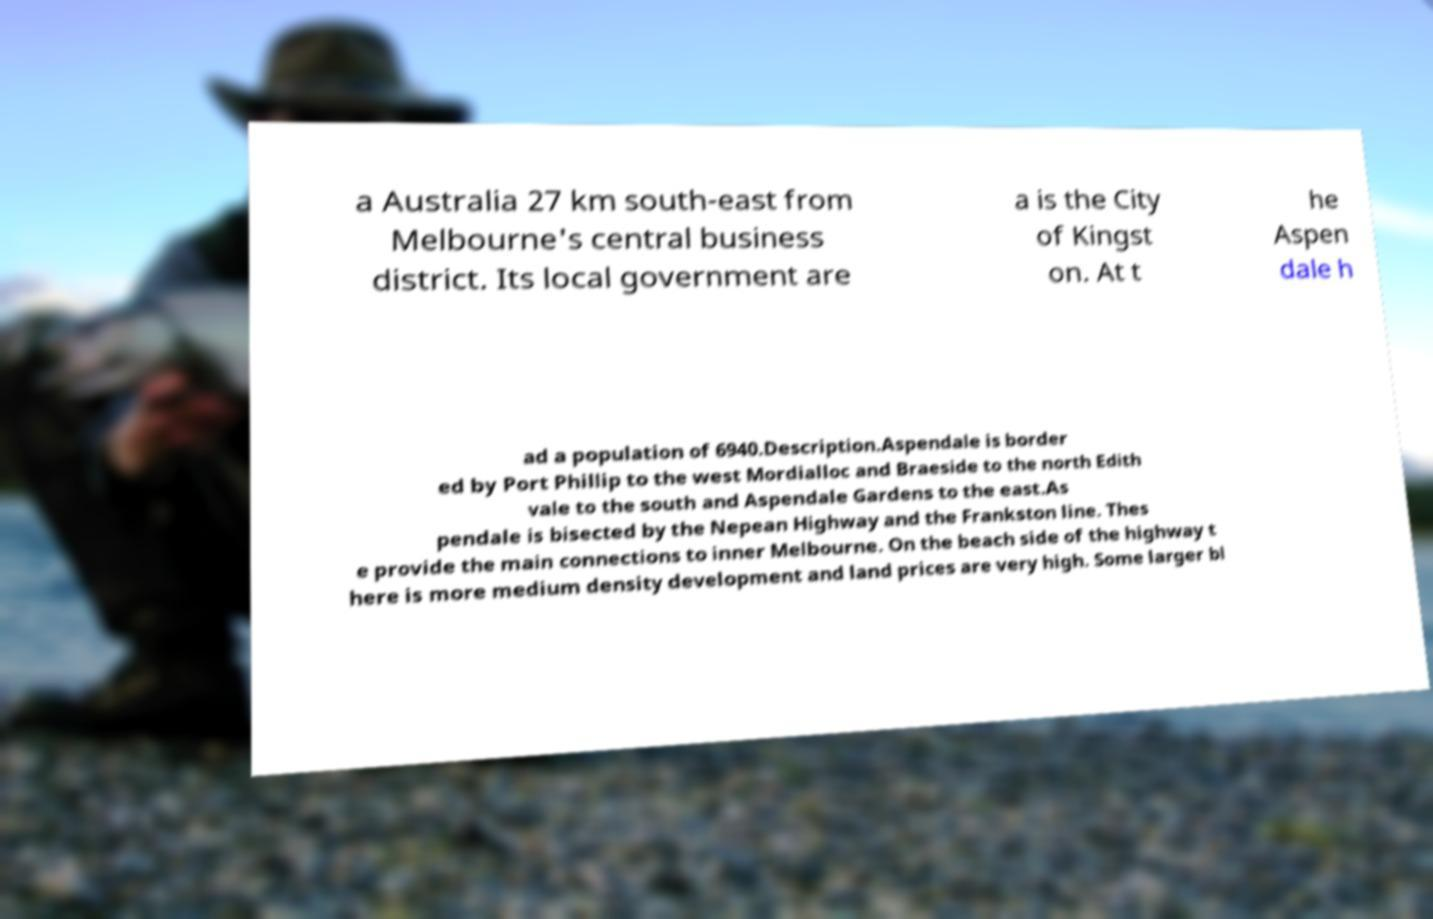Could you extract and type out the text from this image? a Australia 27 km south-east from Melbourne's central business district. Its local government are a is the City of Kingst on. At t he Aspen dale h ad a population of 6940.Description.Aspendale is border ed by Port Phillip to the west Mordialloc and Braeside to the north Edith vale to the south and Aspendale Gardens to the east.As pendale is bisected by the Nepean Highway and the Frankston line. Thes e provide the main connections to inner Melbourne. On the beach side of the highway t here is more medium density development and land prices are very high. Some larger bl 